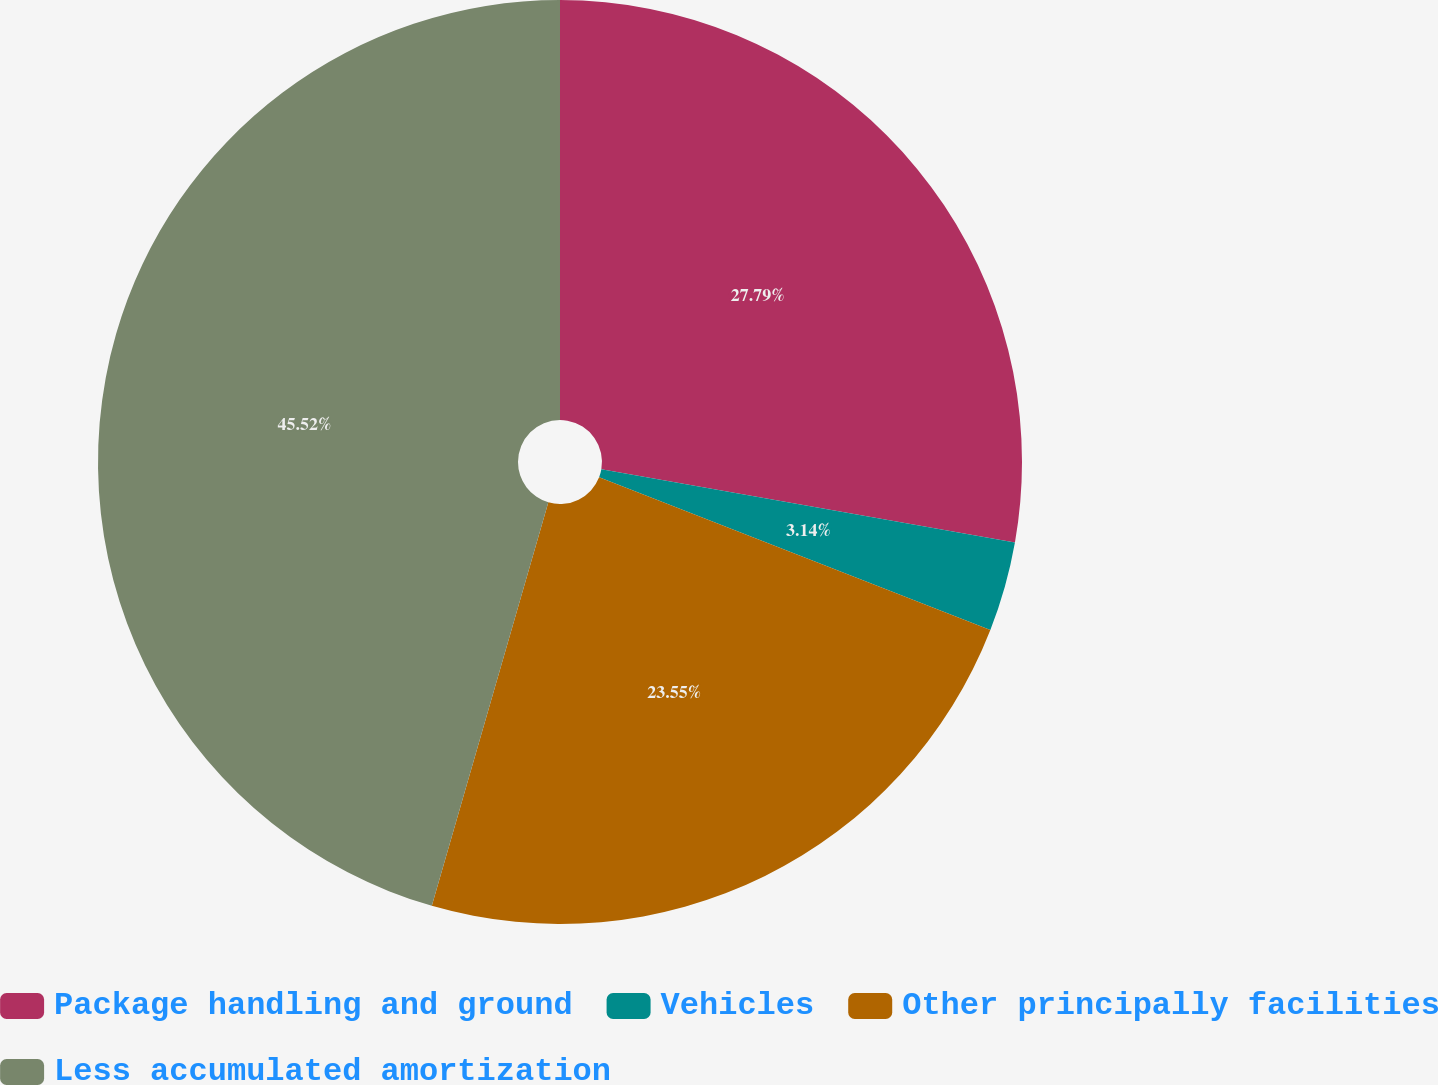<chart> <loc_0><loc_0><loc_500><loc_500><pie_chart><fcel>Package handling and ground<fcel>Vehicles<fcel>Other principally facilities<fcel>Less accumulated amortization<nl><fcel>27.79%<fcel>3.14%<fcel>23.55%<fcel>45.53%<nl></chart> 